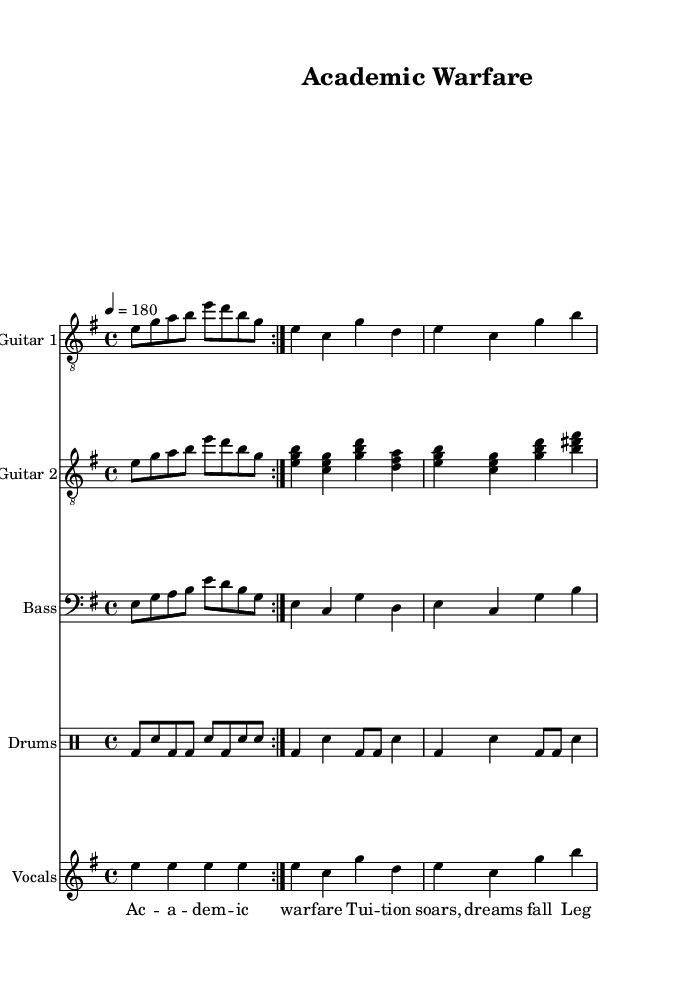What is the key signature of this music? The key signature is E minor, indicated by a single sharp (F#) in the key signature box at the beginning of the staff.
Answer: E minor What is the time signature of this music? The time signature is 4/4, which is noted at the beginning of the score, indicating that there are four beats in a measure and the quarter note gets one beat.
Answer: 4/4 What is the tempo of this piece? The tempo is indicated as 180 beats per minute, written above the staff, which sets a fast pace for the performance.
Answer: 180 How many times is the main riff repeated? The main riff, as seen in the guitar parts, is repeated two times, as denoted by the "volta" marking present in the music.
Answer: 2 What type of instrumentation is used in this piece? The piece features a typical metal band setup that includes two guitars, a bass guitar, drums, and vocals, which is evident from the separate instrument staves shown in the score.
Answer: Two guitars, bass, drums, vocals What thematic element is present in the lyrics of this song? The lyrics critique issues related to higher education, as they refer to "tuition soars" and "legacy admissions," which highlight inequalities within the academic landscape.
Answer: Critique of higher education inequalities What musical genre does this piece represent? The piece represents the thrash metal genre, characterized by its fast-paced rhythms, aggressive guitar riffs, and socially conscious lyrics, evident in the overall structure and tempo of the music.
Answer: Thrash metal 